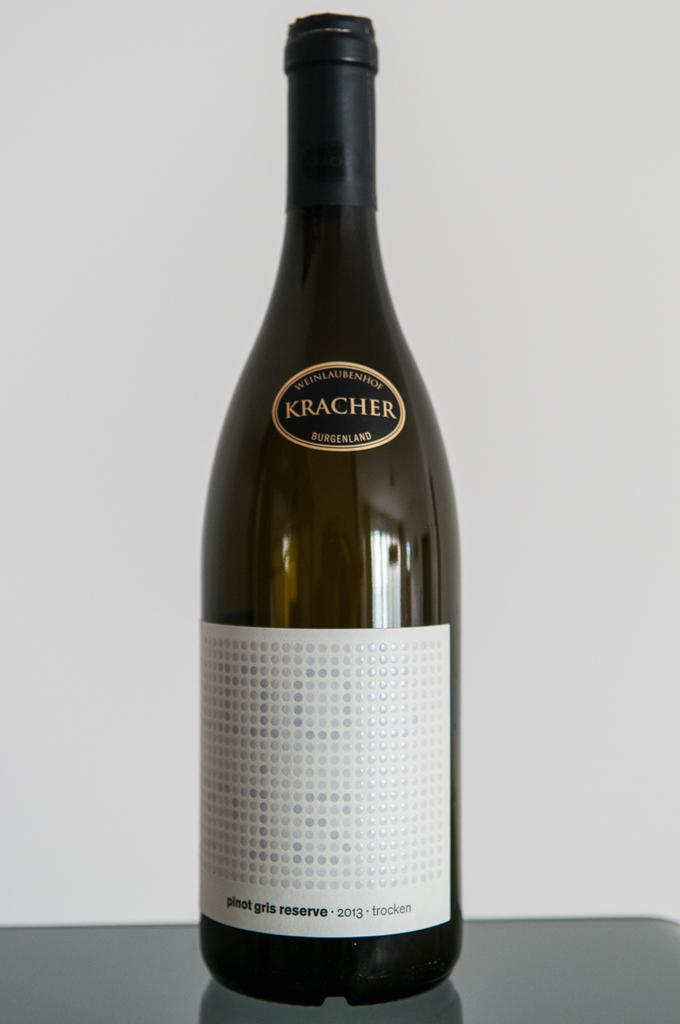<image>
Share a concise interpretation of the image provided. Silver and white dots appear on the label of the Kracher Pinot Gris Reserve 